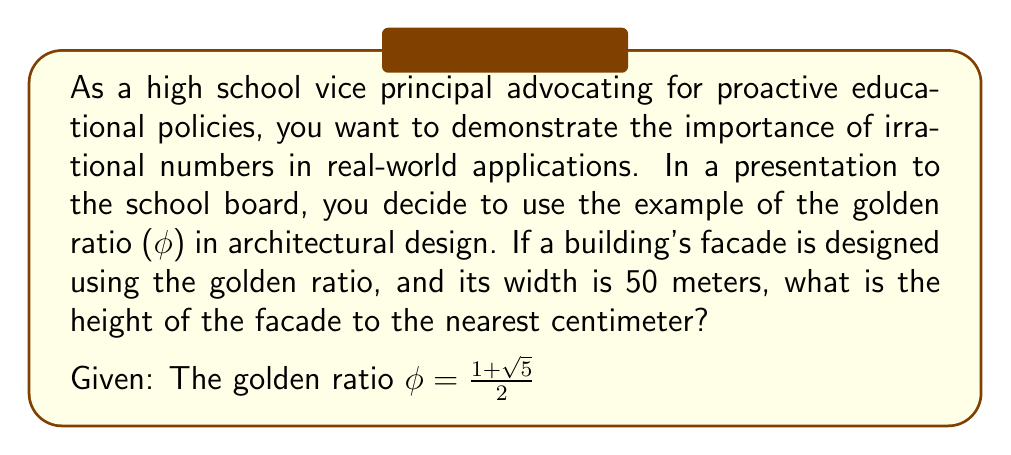Help me with this question. To solve this problem, we'll follow these steps:

1) The golden ratio $\phi$ is defined as the ratio of the longer part to the shorter part of a line segment. In architectural design, this often translates to the ratio of height to width.

2) We are given that the width of the facade is 50 meters. Let's call the height $h$. According to the golden ratio:

   $$\frac{h}{50} = \phi$$

3) We know that $\phi = \frac{1+\sqrt{5}}{2}$. Let's substitute this:

   $$\frac{h}{50} = \frac{1+\sqrt{5}}{2}$$

4) To solve for $h$, multiply both sides by 50:

   $$h = 50 \cdot \frac{1+\sqrt{5}}{2}$$

5) Simplify:

   $$h = 25(1+\sqrt{5})$$

6) Expand the parentheses:

   $$h = 25 + 25\sqrt{5}$$

7) To calculate this, we need to find the value of $\sqrt{5}$:

   $\sqrt{5} \approx 2.236067977$

8) Now we can compute $h$:

   $$h \approx 25 + 25(2.236067977) = 25 + 55.90169943 = 80.90169943$$

9) Rounding to the nearest centimeter (2 decimal places):

   $$h \approx 80.90 \text{ meters}$$

This problem demonstrates how irrational numbers like $\phi$ and $\sqrt{5}$ play a crucial role in architectural design, bridging the gap between pure mathematics and practical applications. It underscores the importance of teaching irrational numbers in high school mathematics curricula.
Answer: 80.90 meters 